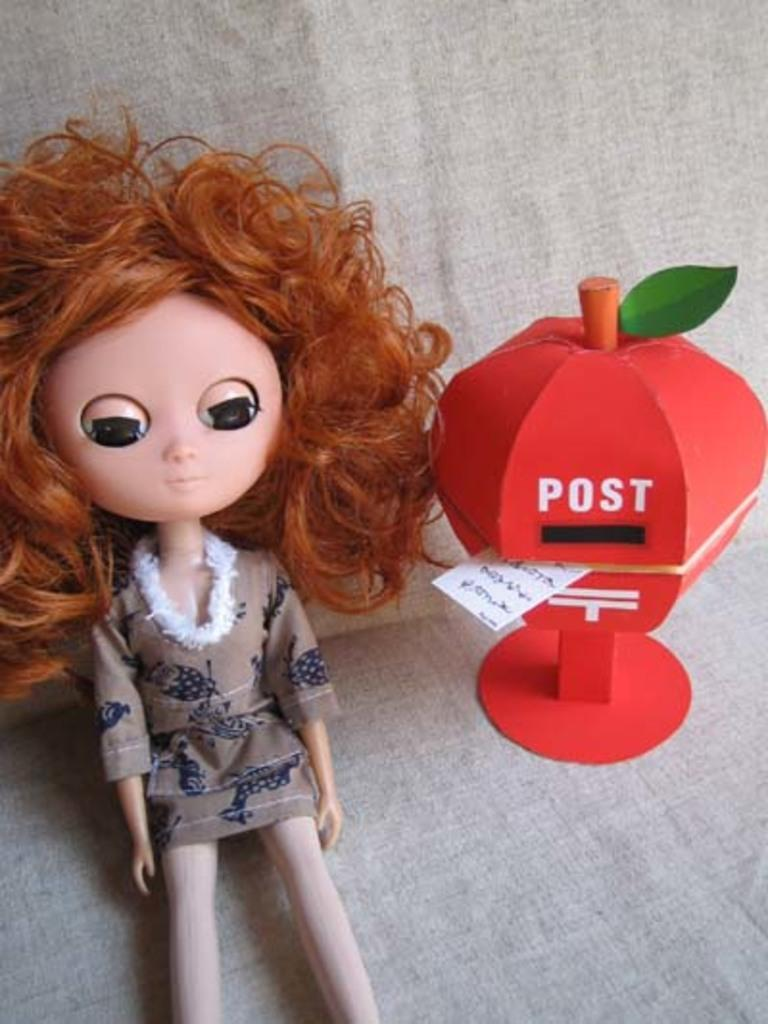What is the main subject of the image? There is a doll in the image. What is the doll wearing? The doll is wearing a blue and grey color dress. Can you describe another object in the image? There is a red and green color object in the image. What is the red and green color object placed on? The red and green color object is on an ash color cloth. How many icicles can be seen hanging from the doll's dress in the image? There are no icicles present in the image, as it features a doll wearing a dress and a red and green color object on an ash color cloth. 